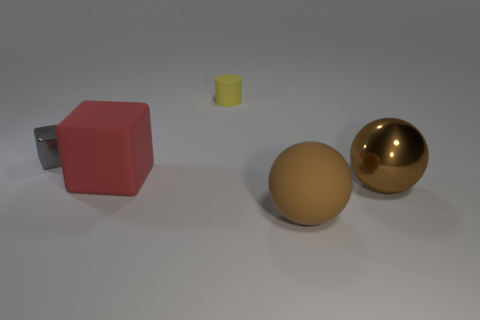Add 4 small shiny things. How many objects exist? 9 Subtract all gray blocks. How many blocks are left? 1 Subtract 1 cubes. How many cubes are left? 1 Subtract all blocks. How many objects are left? 3 Subtract all red cubes. Subtract all gray balls. How many cubes are left? 1 Subtract all tiny yellow cylinders. Subtract all big balls. How many objects are left? 2 Add 4 matte cylinders. How many matte cylinders are left? 5 Add 3 brown metallic objects. How many brown metallic objects exist? 4 Subtract 0 brown cylinders. How many objects are left? 5 